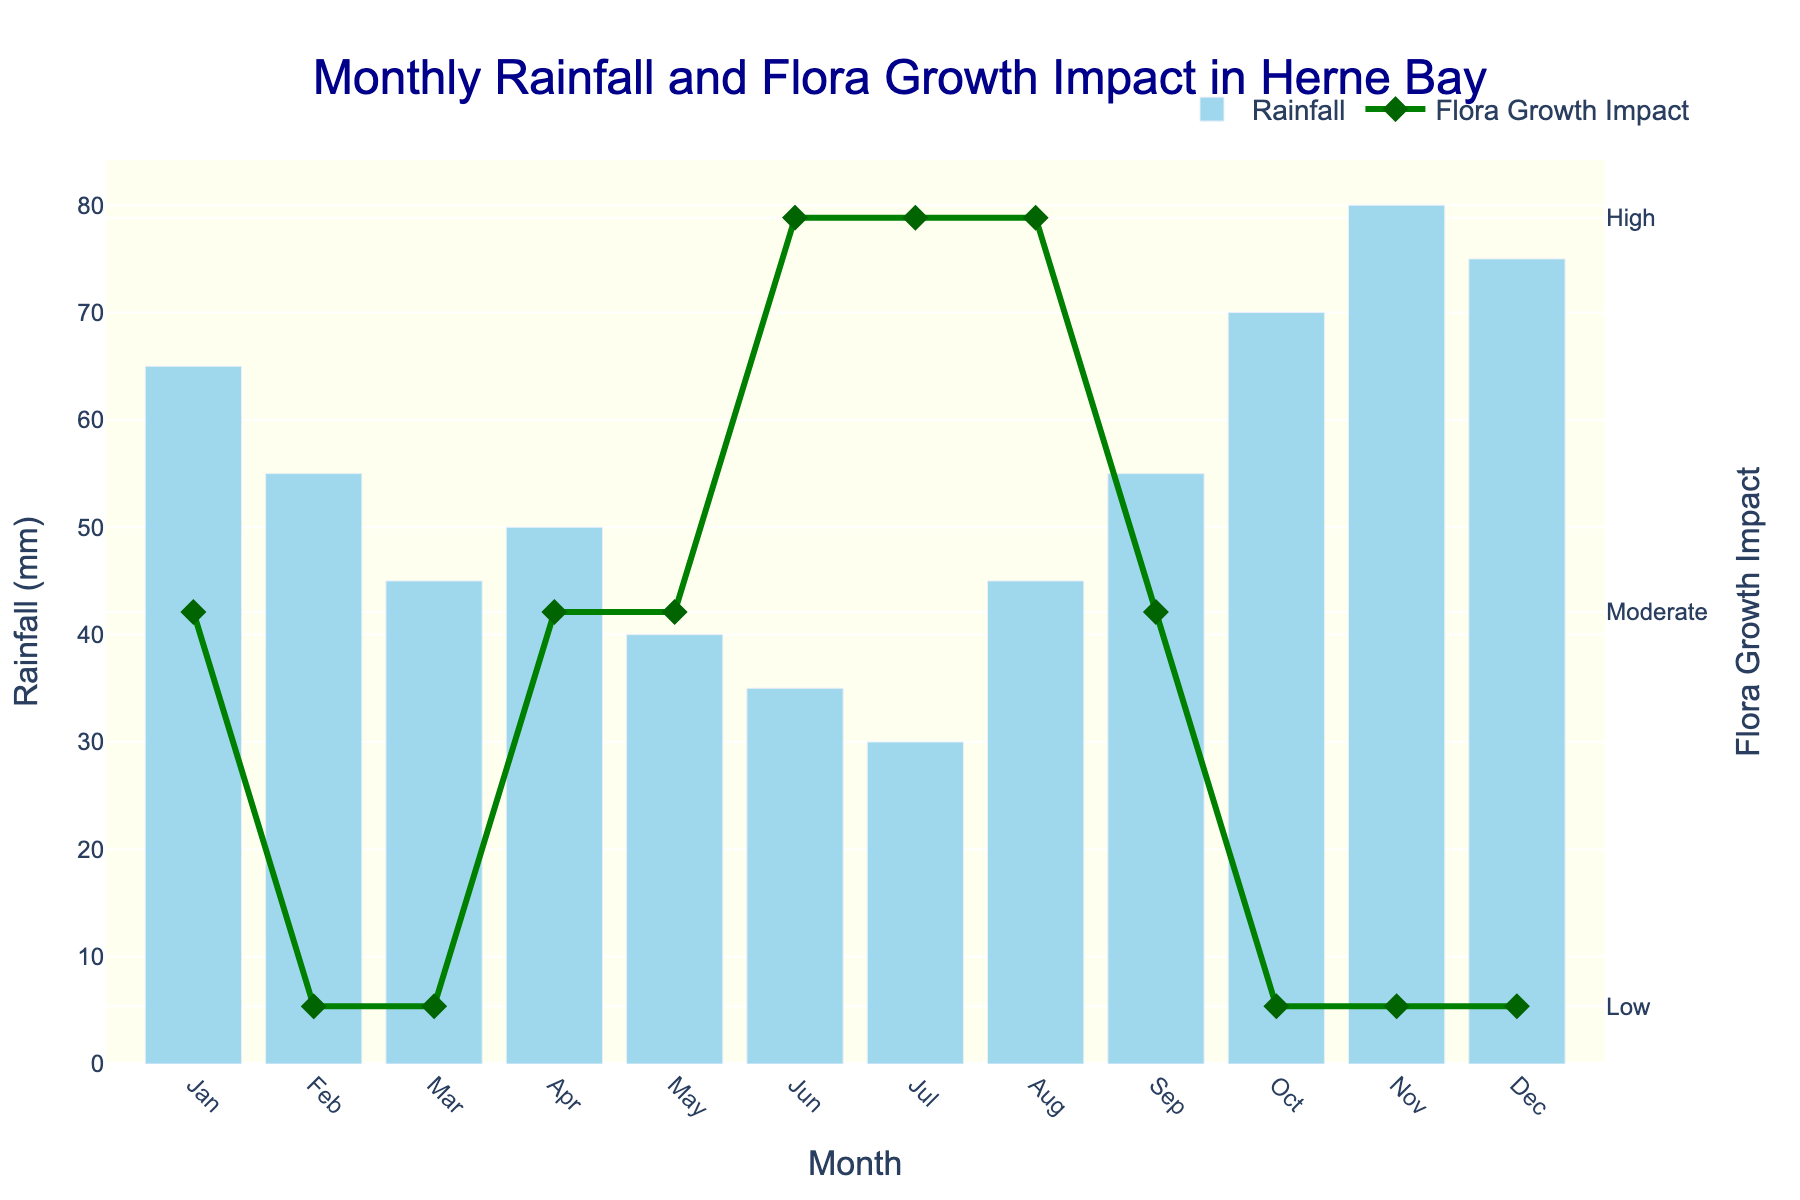Which month had the highest rainfall? To determine the highest rainfall, look for the tallest bar on the chart. The tallest bar corresponds to November.
Answer: November Which month had the highest flora growth impact? The highest flora growth impact corresponds to the highest point on the line chart. This occurs in June, July, and August.
Answer: June, July, August What is the difference in rainfall between October and December? October has rainfall of 70 mm, and December has 75 mm. The difference is 75 mm - 70 mm = 5 mm.
Answer: 5 mm In which months was the flora growth impact marked as "Low"? Look for the months where the line chart drops to the lowest level marked by the y-axis tick labeled "Low". These months are February, March, October, November, and December.
Answer: February, March, October, November, December What is the range of the rainfall across the year? The range of the rainfall is the difference between the maximum and minimum rainfall values. The maximum rainfall is 80 mm (November) and the minimum is 30 mm (July). The range is 80 mm - 30 mm = 50 mm.
Answer: 50 mm How does the rainfall in April compare to that in May? April has a rainfall of 50 mm, while May has 40 mm. April's rainfall is greater than May's by 10 mm.
Answer: April's rainfall is greater What is the average monthly rainfall? Add up all the monthly rainfall values and divide by the number of months. (65 + 55 + 45 + 50 + 40 + 35 + 30 + 45 + 55 + 70 + 80 + 75) / 12 = 645 / 12 = 53.75 mm
Answer: 53.75 mm Which month had the lowest flora growth impact and the highest rainfall simultaneously? Look for the month where the impact line chart is at the "Low" level and the bar is the tallest. November meets these conditions.
Answer: November How many months had a flora growth impact of at least "Moderate"? Count the months where the line chart is at "Moderate" or higher (above "Low"). These months are January, April, May, June, July, August, and September.
Answer: 7 months 